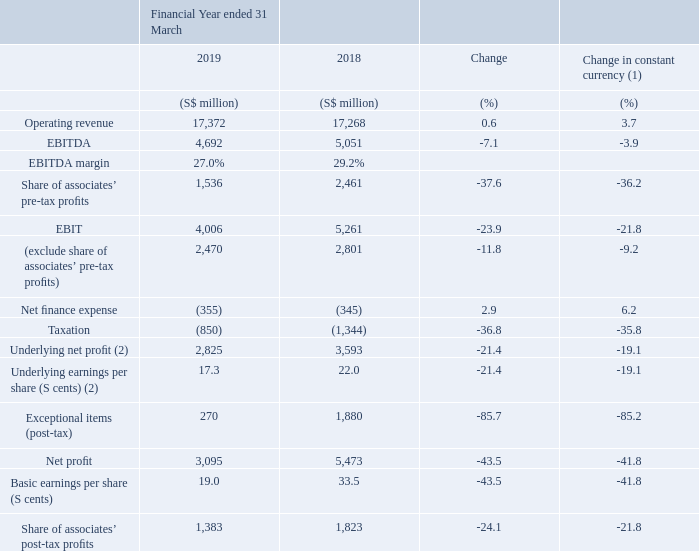Management Discussion and Analysis
Notes: (1) Assuming constant exchange rates for the Australian Dollar, United States Dollar and/or regional currencies (Indian Rupee, Indonesian Rupiah, Philippine Peso and Thai Baht) from the previous year ended 31 March 2018 (FY2018). (2) Underlying net profit refers to net profit before exceptional items.
The Group has executed well on its strategy amid challenging industry, business and economic conditions. The fundamentals of the core businesses remained strong and the Group gained market share in mobile across both Singapore and Australia led by product innovations, content and services. Amobee and Trustwave continued to scale and deepen their capabilities, while the regional associates further monetised the growth in data as smartphone adoption increased. Leveraging on the Group’s strengths and customer base, Singtel continued to build digital ecosystems in payments, gaming and esports. 

The Group has executed well on its strategy amid challenging industry, business and economic conditions. The fundamentals of the core businesses remained strong and the Group gained market share in mobile across both Singapore and Australia led by product innovations, content and services. Amobee and Trustwave continued to scale and deepen their capabilities, while the regional associates further monetised the growth in data as smartphone adoption increased. Leveraging on the Group’s strengths and customer base, Singtel continued to build digital ecosystems in payments, gaming and esports.
In constant currency terms, operating revenue grew 3.7% driven by increases in ICT, digital services and equipment sales. However, EBITDA was down 3.9% mainly due to lower legacy carriage services especially voice, and price erosion. With 6% depreciation in the Australian Dollar, operating revenue was stable while EBITDA declined 7.1%.
Depreciation and amortisation charges fell 1.2% but rose 2.7% in constant currency terms, on increased investments in mobile infrastructure network, spectrum and project related capital spending.  Depreciation and amortisation charges fell 1.2% but rose 2.7% in constant currency terms, on increased investments in mobile infrastructure network, spectrum and project related capital spending.
Consequently, the Group’s EBIT (before the associates’ contributions) declined 12% and would have been down 9.2% in constant currency terms. 

Consequently, the Group’s EBIT (before the associates’ contributions) declined 12% and would have been down 9.2% in constant currency terms.  Consequently, the Group’s EBIT (before the associates’ contributions) declined 12% and would have been down 9.2% in constant currency terms.
In the emerging markets, the regional associates continued to invest in network, spectrum and content to drive data usage. Pre-tax contributions from the associates declined a steep 38% mainly due to Airtel and Telkomsel, the Group’s two largest regional associates. Airtel recorded operating losses on sustained pricing pressures in the Indian mobile market. Telkomsel’s earnings fell on lower revenue due to fierce competition in Indonesia in the earlier part of the financial year when the mandatory SIM card registration exercise took effect. Including associates’ contributions, the Group’s EBIT was S$4.01 billion, down 24% from last year.
Net finance expense was up 2.9% on lower dividend income from the Southern Cross consortium and higher interest expense from increased borrowings.
With lower contributions from the associates, underlying net profit declined by 21%. Exceptional gain was lower as FY 2018 was boosted by a S$2.03 billion of gain on the divestment of units in NetLink Trust. Consequently, the Group recorded a net profit of S$3.10 billion, down 44% from last year. 

With lower contributions from the associates, underlying net profit declined by 21%. Exceptional gain was lower as FY 2018 was boosted by a S$2.03 billion of gain on the divestment of units in NetLink Trust. Consequently, the Group recorded a net profit of S$3.10 billion, down 44% from last year.
The Group has successfully diversified its earnings base through its expansion and investments in overseas markets. On a proportionate basis if the associates are consolidated line-byline, operations outside Singapore accounted for three-quarters of both the Group’s proportionate revenue and EBITDA.
The Group’s financial position and cash flow generation remained strong as at 31 March 2019. Free cash flow for the year was up 1.2% to S$3.65 billion.
Why did operating revenue increase? Increases in ict, digital services and equipment sales. What was the free cash flow for the year? S$3.65 billion. Who are the group's two largest regional associates? Airtel, telkomsel. What is the % change in EBITDA margin from 2018 to 2019?
Answer scale should be: percent. 27% - 29.2% 
Answer: -2.2. What is the change in net profit from 2018 to 2019 in absolute numbers?
Answer scale should be: million. 3,095 - 5,473 
Answer: -2378. Which year (2018 or 2019) had higher basic earnings per share? 33.5 (2018) > 19.0 (2019)
Answer: 2018. 